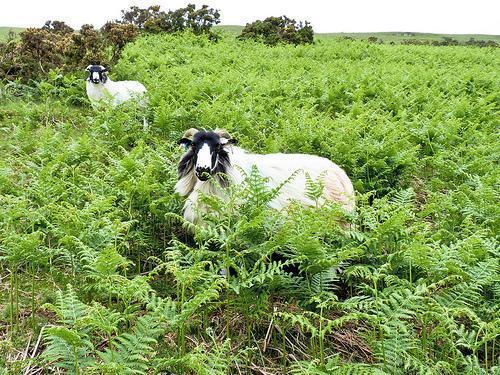How many goats have one leg in the air?
Give a very brief answer. 0. 